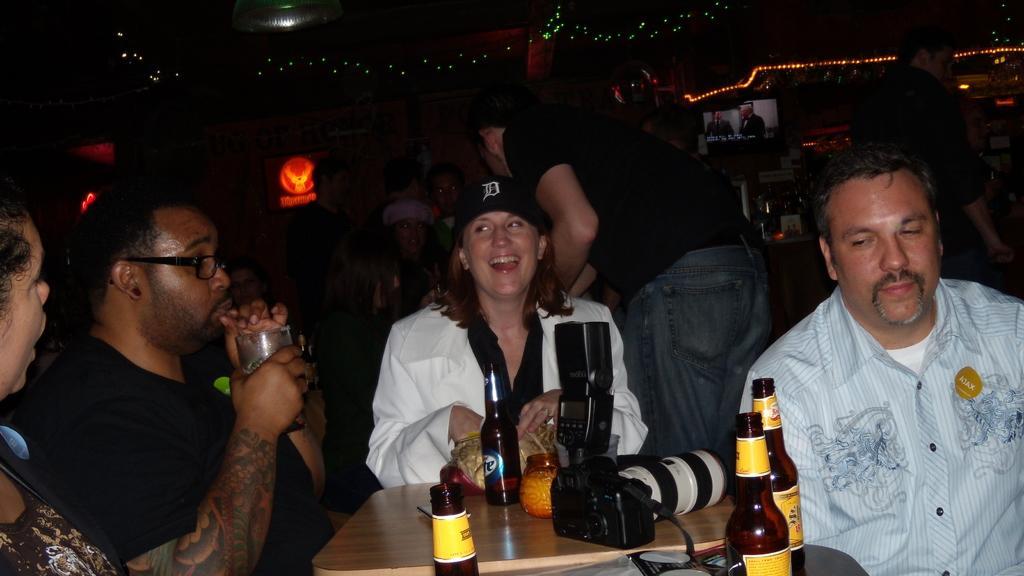Describe this image in one or two sentences. There are group of people sitting in chairs and there is a table in front them which has drink bottles and a camera on it and there are group of people in the background. 